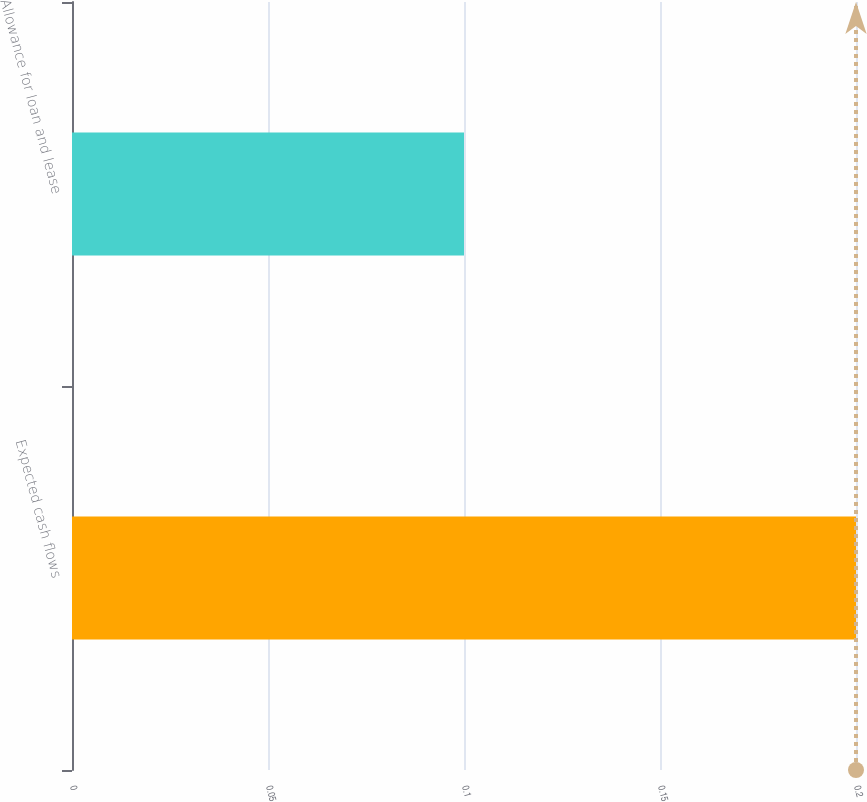Convert chart. <chart><loc_0><loc_0><loc_500><loc_500><bar_chart><fcel>Expected cash flows<fcel>Allowance for loan and lease<nl><fcel>0.2<fcel>0.1<nl></chart> 